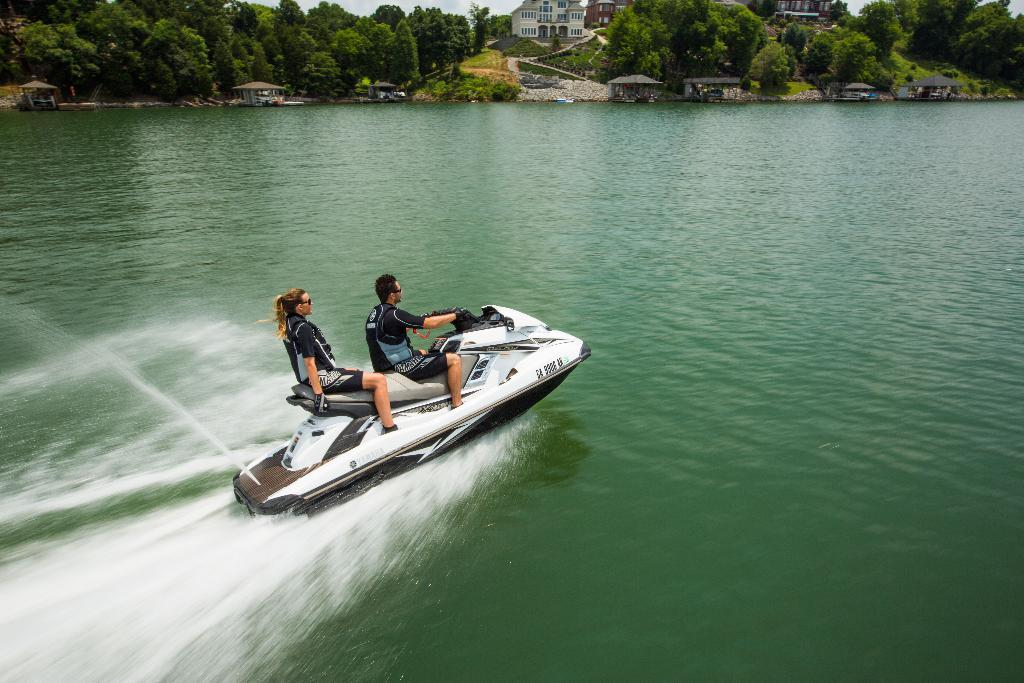What is the main subject of the image? The main subject of the image is a person riding a boat. Are there any other people in the image? Yes, there is another person sitting in the boat. What is the primary mode of transportation in the image? The primary mode of transportation in the image is a boat. What type of food is being prepared by the person riding the boat? There is no indication of food preparation in the image; it only shows a person riding a boat and another person sitting in the boat. 